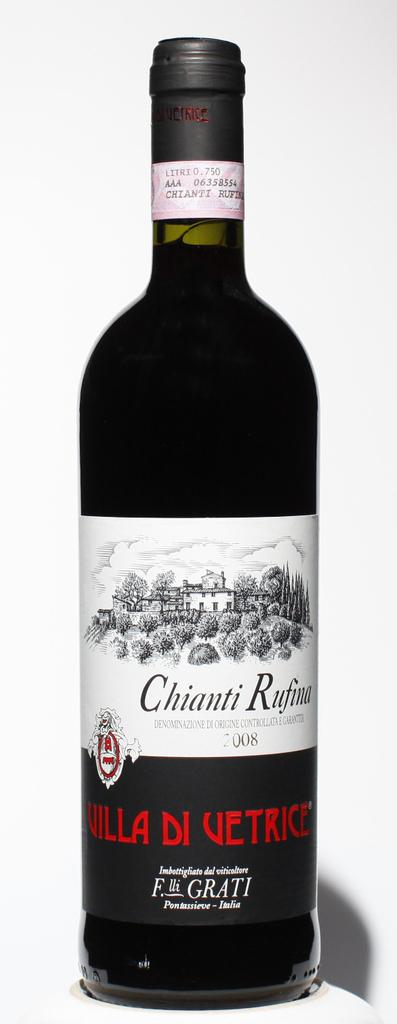<image>
Render a clear and concise summary of the photo. Wine that has Chianti written on the front 